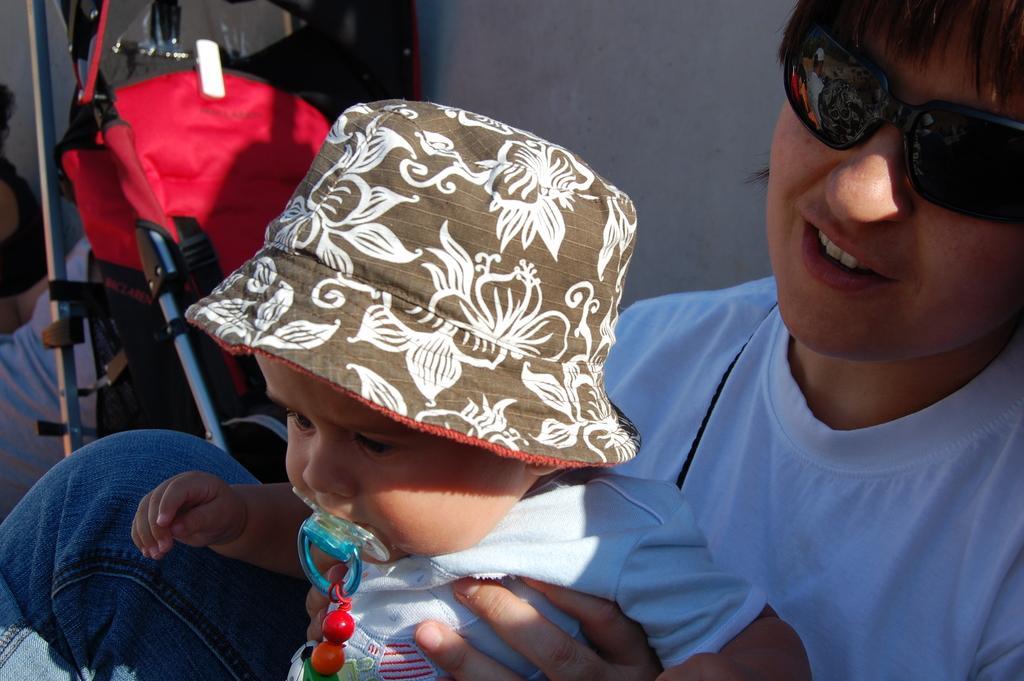In one or two sentences, can you explain what this image depicts? On the right side, there is a person in white color t-shirt, wearing sunglasses, smiling and holding a baby. In the background, there is white wall and there is another person. 